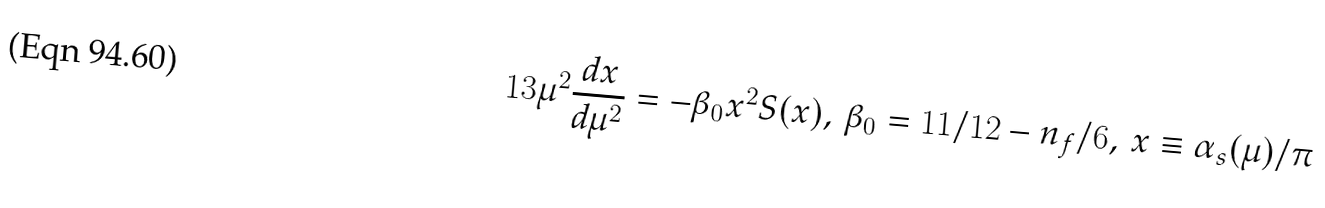Convert formula to latex. <formula><loc_0><loc_0><loc_500><loc_500>1 3 \mu ^ { 2 } \frac { d x } { d \mu ^ { 2 } } = - \beta _ { 0 } x ^ { 2 } S ( x ) , \, \beta _ { 0 } = 1 1 / 1 2 - n _ { f } / 6 , \, x \equiv \alpha _ { s } ( \mu ) / \pi</formula> 